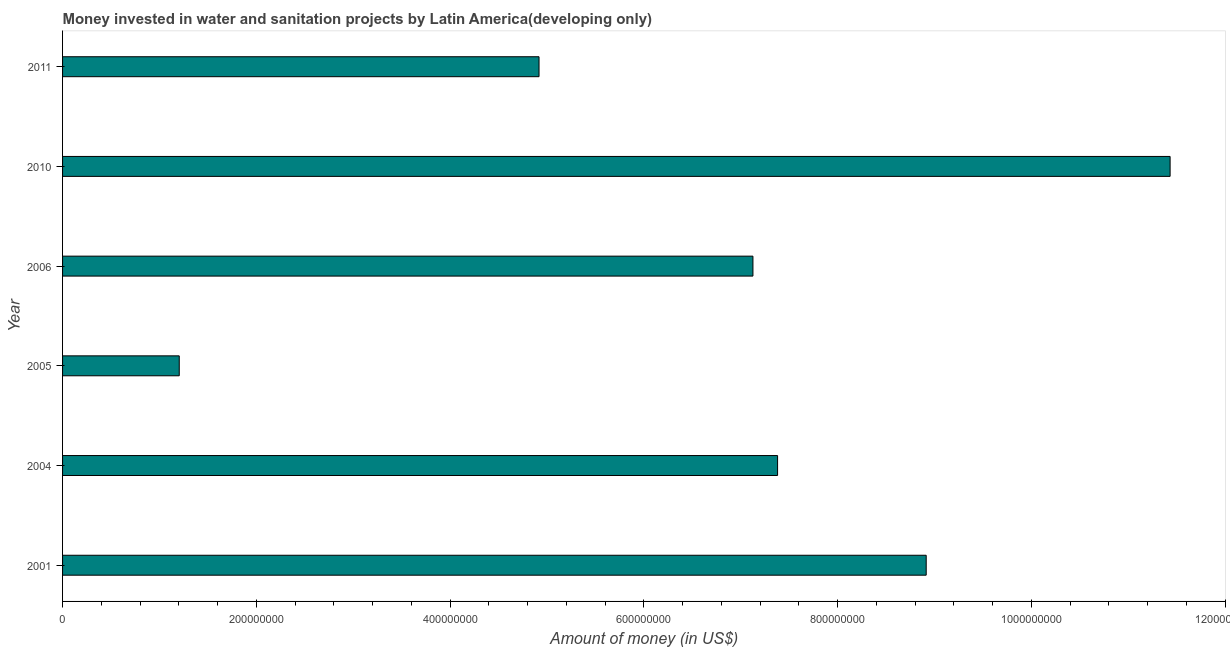Does the graph contain any zero values?
Make the answer very short. No. What is the title of the graph?
Provide a succinct answer. Money invested in water and sanitation projects by Latin America(developing only). What is the label or title of the X-axis?
Ensure brevity in your answer.  Amount of money (in US$). What is the label or title of the Y-axis?
Your answer should be very brief. Year. What is the investment in 2001?
Ensure brevity in your answer.  8.91e+08. Across all years, what is the maximum investment?
Your answer should be very brief. 1.14e+09. Across all years, what is the minimum investment?
Provide a short and direct response. 1.20e+08. What is the sum of the investment?
Offer a terse response. 4.10e+09. What is the difference between the investment in 2005 and 2006?
Provide a short and direct response. -5.92e+08. What is the average investment per year?
Keep it short and to the point. 6.83e+08. What is the median investment?
Provide a succinct answer. 7.25e+08. Do a majority of the years between 2006 and 2010 (inclusive) have investment greater than 560000000 US$?
Make the answer very short. Yes. What is the ratio of the investment in 2006 to that in 2010?
Give a very brief answer. 0.62. Is the difference between the investment in 2005 and 2010 greater than the difference between any two years?
Give a very brief answer. Yes. What is the difference between the highest and the second highest investment?
Ensure brevity in your answer.  2.52e+08. Is the sum of the investment in 2005 and 2011 greater than the maximum investment across all years?
Provide a short and direct response. No. What is the difference between the highest and the lowest investment?
Provide a succinct answer. 1.02e+09. How many bars are there?
Ensure brevity in your answer.  6. Are all the bars in the graph horizontal?
Provide a short and direct response. Yes. Are the values on the major ticks of X-axis written in scientific E-notation?
Keep it short and to the point. No. What is the Amount of money (in US$) of 2001?
Your response must be concise. 8.91e+08. What is the Amount of money (in US$) in 2004?
Provide a short and direct response. 7.38e+08. What is the Amount of money (in US$) in 2005?
Offer a very short reply. 1.20e+08. What is the Amount of money (in US$) of 2006?
Your response must be concise. 7.13e+08. What is the Amount of money (in US$) of 2010?
Ensure brevity in your answer.  1.14e+09. What is the Amount of money (in US$) of 2011?
Ensure brevity in your answer.  4.92e+08. What is the difference between the Amount of money (in US$) in 2001 and 2004?
Ensure brevity in your answer.  1.53e+08. What is the difference between the Amount of money (in US$) in 2001 and 2005?
Keep it short and to the point. 7.71e+08. What is the difference between the Amount of money (in US$) in 2001 and 2006?
Your answer should be compact. 1.79e+08. What is the difference between the Amount of money (in US$) in 2001 and 2010?
Your answer should be compact. -2.52e+08. What is the difference between the Amount of money (in US$) in 2001 and 2011?
Make the answer very short. 4.00e+08. What is the difference between the Amount of money (in US$) in 2004 and 2005?
Your answer should be very brief. 6.18e+08. What is the difference between the Amount of money (in US$) in 2004 and 2006?
Offer a terse response. 2.54e+07. What is the difference between the Amount of money (in US$) in 2004 and 2010?
Offer a very short reply. -4.05e+08. What is the difference between the Amount of money (in US$) in 2004 and 2011?
Make the answer very short. 2.46e+08. What is the difference between the Amount of money (in US$) in 2005 and 2006?
Keep it short and to the point. -5.92e+08. What is the difference between the Amount of money (in US$) in 2005 and 2010?
Keep it short and to the point. -1.02e+09. What is the difference between the Amount of money (in US$) in 2005 and 2011?
Offer a terse response. -3.71e+08. What is the difference between the Amount of money (in US$) in 2006 and 2010?
Your answer should be compact. -4.31e+08. What is the difference between the Amount of money (in US$) in 2006 and 2011?
Offer a terse response. 2.21e+08. What is the difference between the Amount of money (in US$) in 2010 and 2011?
Your response must be concise. 6.51e+08. What is the ratio of the Amount of money (in US$) in 2001 to that in 2004?
Offer a terse response. 1.21. What is the ratio of the Amount of money (in US$) in 2001 to that in 2005?
Your response must be concise. 7.4. What is the ratio of the Amount of money (in US$) in 2001 to that in 2006?
Provide a short and direct response. 1.25. What is the ratio of the Amount of money (in US$) in 2001 to that in 2010?
Your answer should be very brief. 0.78. What is the ratio of the Amount of money (in US$) in 2001 to that in 2011?
Your answer should be compact. 1.81. What is the ratio of the Amount of money (in US$) in 2004 to that in 2005?
Give a very brief answer. 6.13. What is the ratio of the Amount of money (in US$) in 2004 to that in 2006?
Your answer should be very brief. 1.04. What is the ratio of the Amount of money (in US$) in 2004 to that in 2010?
Keep it short and to the point. 0.65. What is the ratio of the Amount of money (in US$) in 2004 to that in 2011?
Offer a terse response. 1.5. What is the ratio of the Amount of money (in US$) in 2005 to that in 2006?
Provide a short and direct response. 0.17. What is the ratio of the Amount of money (in US$) in 2005 to that in 2010?
Give a very brief answer. 0.1. What is the ratio of the Amount of money (in US$) in 2005 to that in 2011?
Your answer should be very brief. 0.24. What is the ratio of the Amount of money (in US$) in 2006 to that in 2010?
Keep it short and to the point. 0.62. What is the ratio of the Amount of money (in US$) in 2006 to that in 2011?
Ensure brevity in your answer.  1.45. What is the ratio of the Amount of money (in US$) in 2010 to that in 2011?
Your answer should be compact. 2.33. 